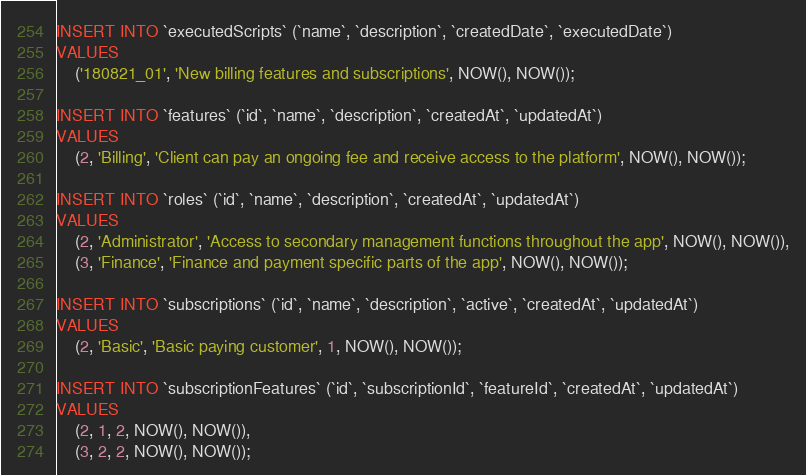<code> <loc_0><loc_0><loc_500><loc_500><_SQL_>INSERT INTO `executedScripts` (`name`, `description`, `createdDate`, `executedDate`)
VALUES
	('180821_01', 'New billing features and subscriptions', NOW(), NOW());

INSERT INTO `features` (`id`, `name`, `description`, `createdAt`, `updatedAt`)
VALUES
	(2, 'Billing', 'Client can pay an ongoing fee and receive access to the platform', NOW(), NOW());

INSERT INTO `roles` (`id`, `name`, `description`, `createdAt`, `updatedAt`)
VALUES
	(2, 'Administrator', 'Access to secondary management functions throughout the app', NOW(), NOW()),
	(3, 'Finance', 'Finance and payment specific parts of the app', NOW(), NOW());

INSERT INTO `subscriptions` (`id`, `name`, `description`, `active`, `createdAt`, `updatedAt`)
VALUES
	(2, 'Basic', 'Basic paying customer', 1, NOW(), NOW());

INSERT INTO `subscriptionFeatures` (`id`, `subscriptionId`, `featureId`, `createdAt`, `updatedAt`)
VALUES
	(2, 1, 2, NOW(), NOW()),
	(3, 2, 2, NOW(), NOW());
</code> 